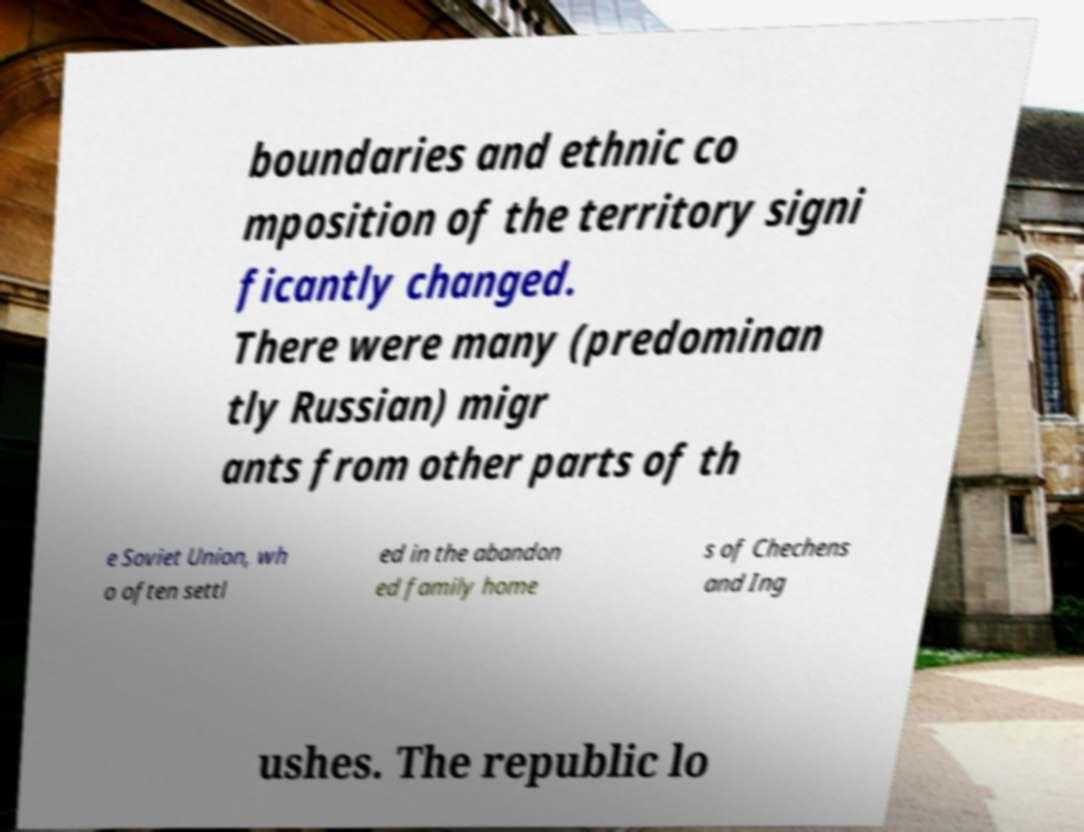For documentation purposes, I need the text within this image transcribed. Could you provide that? boundaries and ethnic co mposition of the territory signi ficantly changed. There were many (predominan tly Russian) migr ants from other parts of th e Soviet Union, wh o often settl ed in the abandon ed family home s of Chechens and Ing ushes. The republic lo 